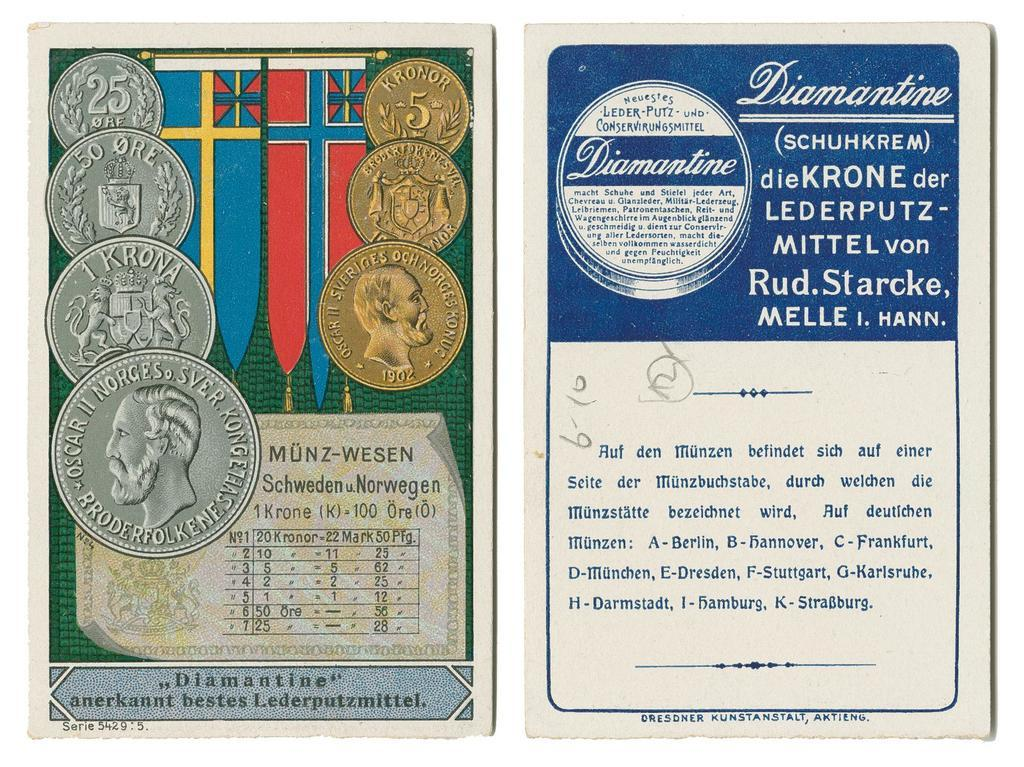<image>
Summarize the visual content of the image. A postcard in German displays silver and gold foreign coins. 